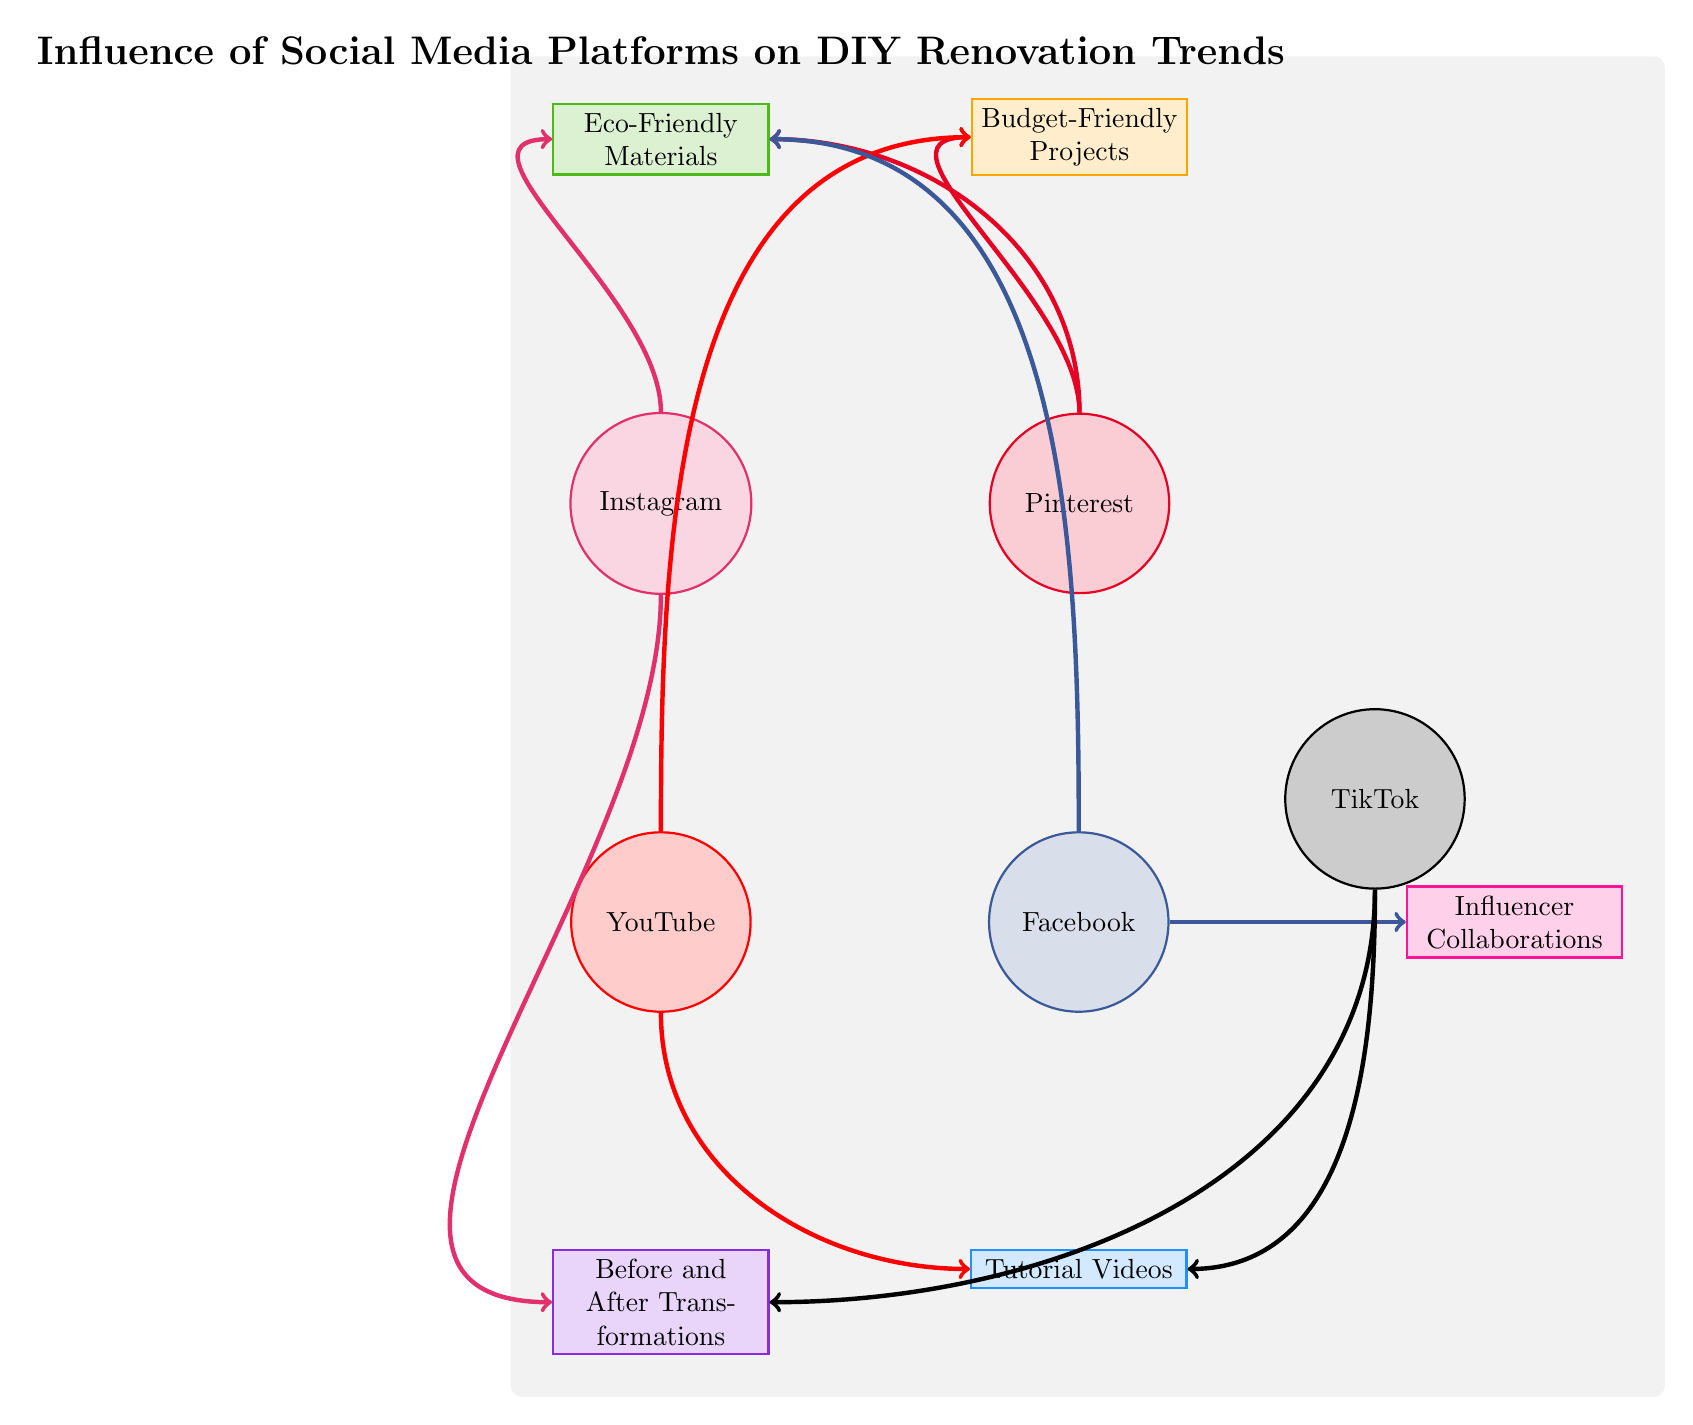What is the total number of nodes in the diagram? To find the total number of nodes, we count the distinct circles and rectangles in the diagram. There are five social media platforms and five different DIY renovation trends, totaling ten nodes.
Answer: 10 Which social media platform is connected to Eco-Friendly Materials? We look at the edges going from the nodes representing social media platforms to identify which one connects to Eco-Friendly Materials. The platforms Instagram, Pinterest, and Facebook all have direct connections to Eco-Friendly Materials.
Answer: Instagram, Pinterest, Facebook How many connections does YouTube have? We examine YouTube in the diagram and count the arrows emanating from it to determine its connections. YouTube has two outgoing connections: one to Tutorial Videos and another to Budget-Friendly Projects.
Answer: 2 Which platform has the most connections? By analyzing the number of outgoing links for each social media platform, we assess that Instagram has the most connections (two), along with Pinterest and Facebook (each also has two), while others have one or none.
Answer: Instagram, Pinterest, Facebook What type of projects does TikTok connect with? To answer this, we trace the links emerging from TikTok in the diagram. TikTok connects to Before and After Transformations and Tutorial Videos.
Answer: Before and After Transformations, Tutorial Videos Which social media platform links to both Budget-Friendly Projects and Tutorial Videos? We investigate the connections of all platforms and find that YouTube is the only platform connected to both Budget-Friendly Projects and Tutorial Videos via its outgoing arrows.
Answer: YouTube How many unique DIY renovation trends are influenced by Instagram? We examine the edges coming from the Instagram node to see which trends it influences. Instagram links to two trends: Eco-Friendly Materials and Before and After Transformations.
Answer: 2 Which social media platform collaborates with Influencers? By checking the outgoing connections, we see that Facebook is specifically linked to Influencer Collaborations.
Answer: Facebook What is the relationship between Instagram and Before and After Transformations? We look for edges connecting Instagram to Before and After Transformations. The link indicates that Instagram influences this type of project, showcasing an arrow from Instagram to Before and After Transformations.
Answer: Influence 